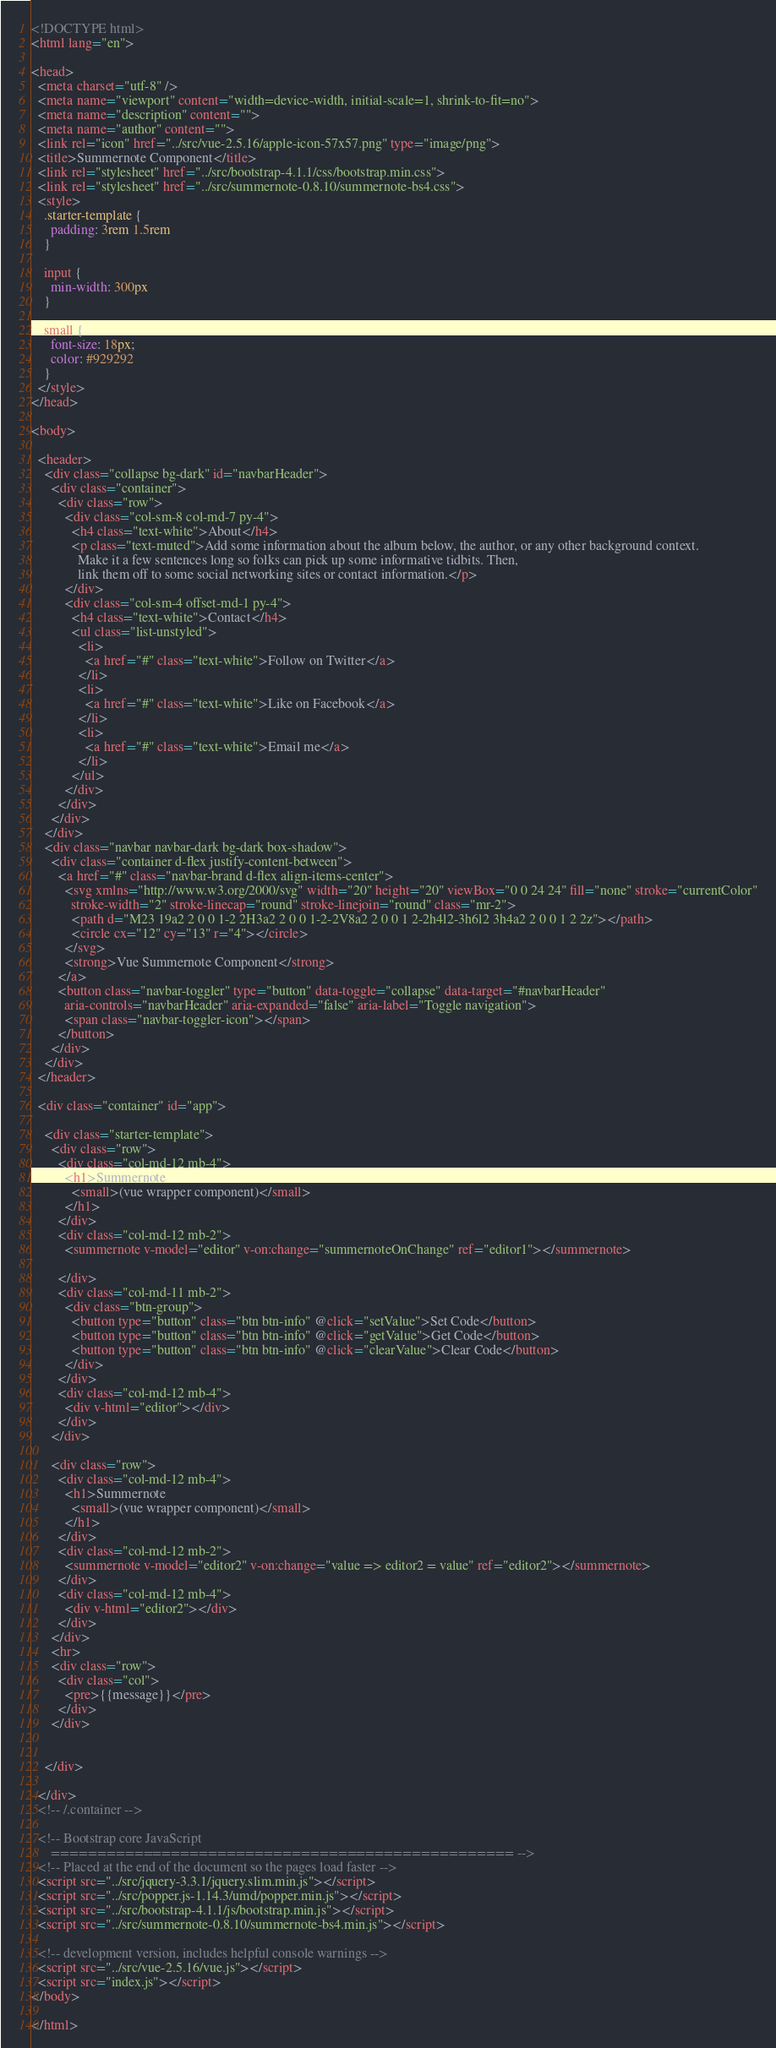Convert code to text. <code><loc_0><loc_0><loc_500><loc_500><_HTML_><!DOCTYPE html>
<html lang="en">

<head>
  <meta charset="utf-8" />
  <meta name="viewport" content="width=device-width, initial-scale=1, shrink-to-fit=no">
  <meta name="description" content="">
  <meta name="author" content="">
  <link rel="icon" href="../src/vue-2.5.16/apple-icon-57x57.png" type="image/png">
  <title>Summernote Component</title>
  <link rel="stylesheet" href="../src/bootstrap-4.1.1/css/bootstrap.min.css">
  <link rel="stylesheet" href="../src/summernote-0.8.10/summernote-bs4.css">
  <style>
    .starter-template {
      padding: 3rem 1.5rem
    }

    input {
      min-width: 300px
    }

    small {
      font-size: 18px;
      color: #929292
    }
  </style>
</head>

<body>

  <header>
    <div class="collapse bg-dark" id="navbarHeader">
      <div class="container">
        <div class="row">
          <div class="col-sm-8 col-md-7 py-4">
            <h4 class="text-white">About</h4>
            <p class="text-muted">Add some information about the album below, the author, or any other background context.
              Make it a few sentences long so folks can pick up some informative tidbits. Then,
              link them off to some social networking sites or contact information.</p>
          </div>
          <div class="col-sm-4 offset-md-1 py-4">
            <h4 class="text-white">Contact</h4>
            <ul class="list-unstyled">
              <li>
                <a href="#" class="text-white">Follow on Twitter</a>
              </li>
              <li>
                <a href="#" class="text-white">Like on Facebook</a>
              </li>
              <li>
                <a href="#" class="text-white">Email me</a>
              </li>
            </ul>
          </div>
        </div>
      </div>
    </div>
    <div class="navbar navbar-dark bg-dark box-shadow">
      <div class="container d-flex justify-content-between">
        <a href="#" class="navbar-brand d-flex align-items-center">
          <svg xmlns="http://www.w3.org/2000/svg" width="20" height="20" viewBox="0 0 24 24" fill="none" stroke="currentColor"
            stroke-width="2" stroke-linecap="round" stroke-linejoin="round" class="mr-2">
            <path d="M23 19a2 2 0 0 1-2 2H3a2 2 0 0 1-2-2V8a2 2 0 0 1 2-2h4l2-3h6l2 3h4a2 2 0 0 1 2 2z"></path>
            <circle cx="12" cy="13" r="4"></circle>
          </svg>
          <strong>Vue Summernote Component</strong>
        </a>
        <button class="navbar-toggler" type="button" data-toggle="collapse" data-target="#navbarHeader"
          aria-controls="navbarHeader" aria-expanded="false" aria-label="Toggle navigation">
          <span class="navbar-toggler-icon"></span>
        </button>
      </div>
    </div>
  </header>

  <div class="container" id="app">

    <div class="starter-template">
      <div class="row">
        <div class="col-md-12 mb-4">
          <h1>Summernote
            <small>(vue wrapper component)</small>
          </h1>
        </div>
        <div class="col-md-12 mb-2">
          <summernote v-model="editor" v-on:change="summernoteOnChange" ref="editor1"></summernote>

        </div>
        <div class="col-md-11 mb-2">
          <div class="btn-group">
            <button type="button" class="btn btn-info" @click="setValue">Set Code</button>
            <button type="button" class="btn btn-info" @click="getValue">Get Code</button>
            <button type="button" class="btn btn-info" @click="clearValue">Clear Code</button>
          </div>
        </div>
        <div class="col-md-12 mb-4">
          <div v-html="editor"></div>
        </div>
      </div>

      <div class="row">
        <div class="col-md-12 mb-4">
          <h1>Summernote
            <small>(vue wrapper component)</small>
          </h1>
        </div>
        <div class="col-md-12 mb-2">
          <summernote v-model="editor2" v-on:change="value => editor2 = value" ref="editor2"></summernote>
        </div>
        <div class="col-md-12 mb-4">
          <div v-html="editor2"></div>
        </div>
      </div>
      <hr>
      <div class="row">
        <div class="col">
          <pre>{{message}}</pre>
        </div>
      </div>


    </div>

  </div>
  <!-- /.container -->

  <!-- Bootstrap core JavaScript
      ================================================== -->
  <!-- Placed at the end of the document so the pages load faster -->
  <script src="../src/jquery-3.3.1/jquery.slim.min.js"></script>
  <script src="../src/popper.js-1.14.3/umd/popper.min.js"></script>
  <script src="../src/bootstrap-4.1.1/js/bootstrap.min.js"></script>
  <script src="../src/summernote-0.8.10/summernote-bs4.min.js"></script>

  <!-- development version, includes helpful console warnings -->
  <script src="../src/vue-2.5.16/vue.js"></script>
  <script src="index.js"></script>
</body>

</html>
</code> 